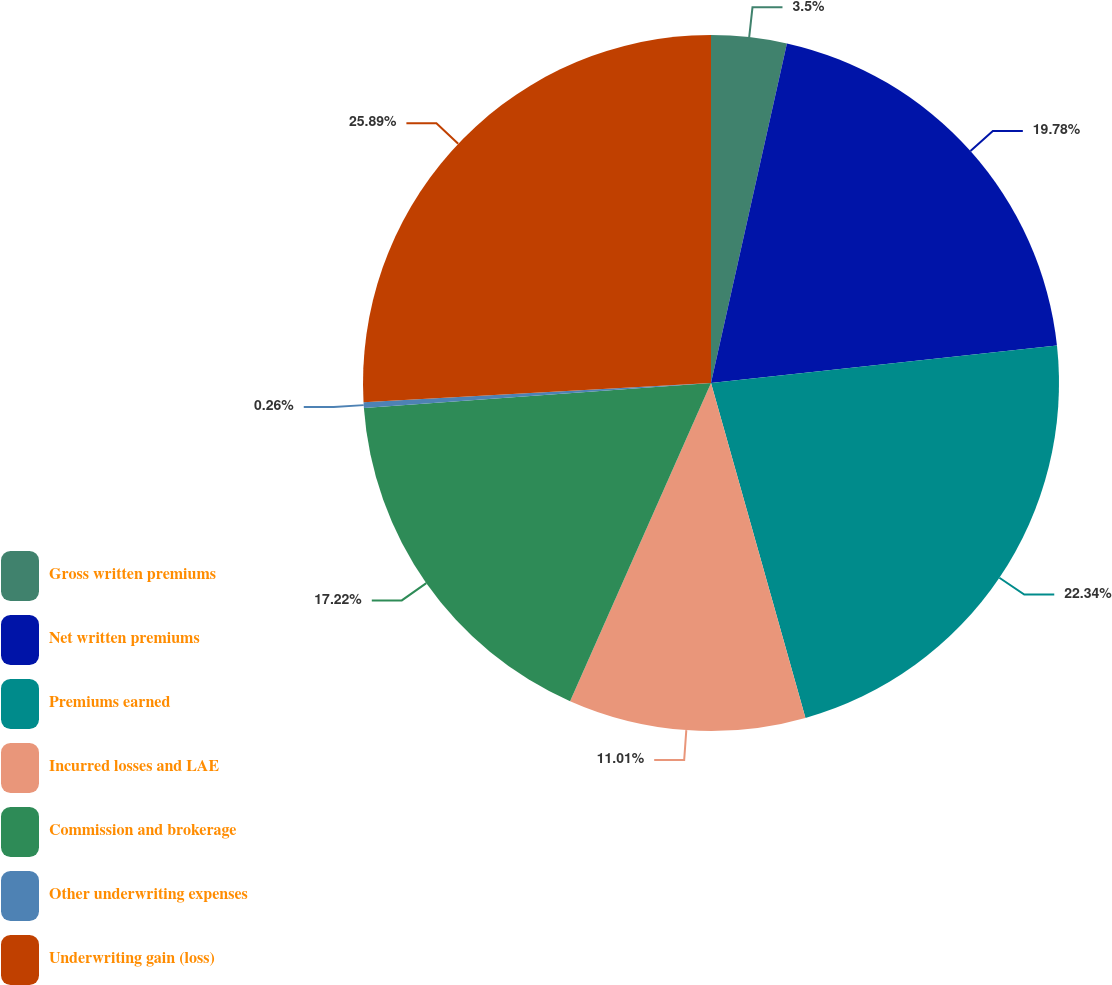<chart> <loc_0><loc_0><loc_500><loc_500><pie_chart><fcel>Gross written premiums<fcel>Net written premiums<fcel>Premiums earned<fcel>Incurred losses and LAE<fcel>Commission and brokerage<fcel>Other underwriting expenses<fcel>Underwriting gain (loss)<nl><fcel>3.5%<fcel>19.78%<fcel>22.34%<fcel>11.01%<fcel>17.22%<fcel>0.26%<fcel>25.88%<nl></chart> 